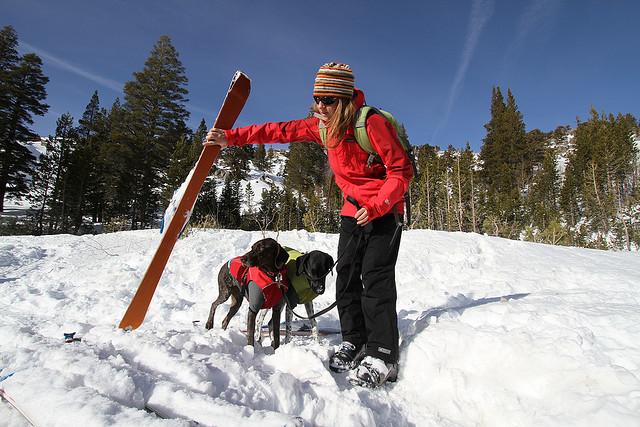What is the ground covered with?
Concise answer only. Snow. What color is the woman's jacket?
Write a very short answer. Red. How many dogs are in this photograph?
Keep it brief. 2. 